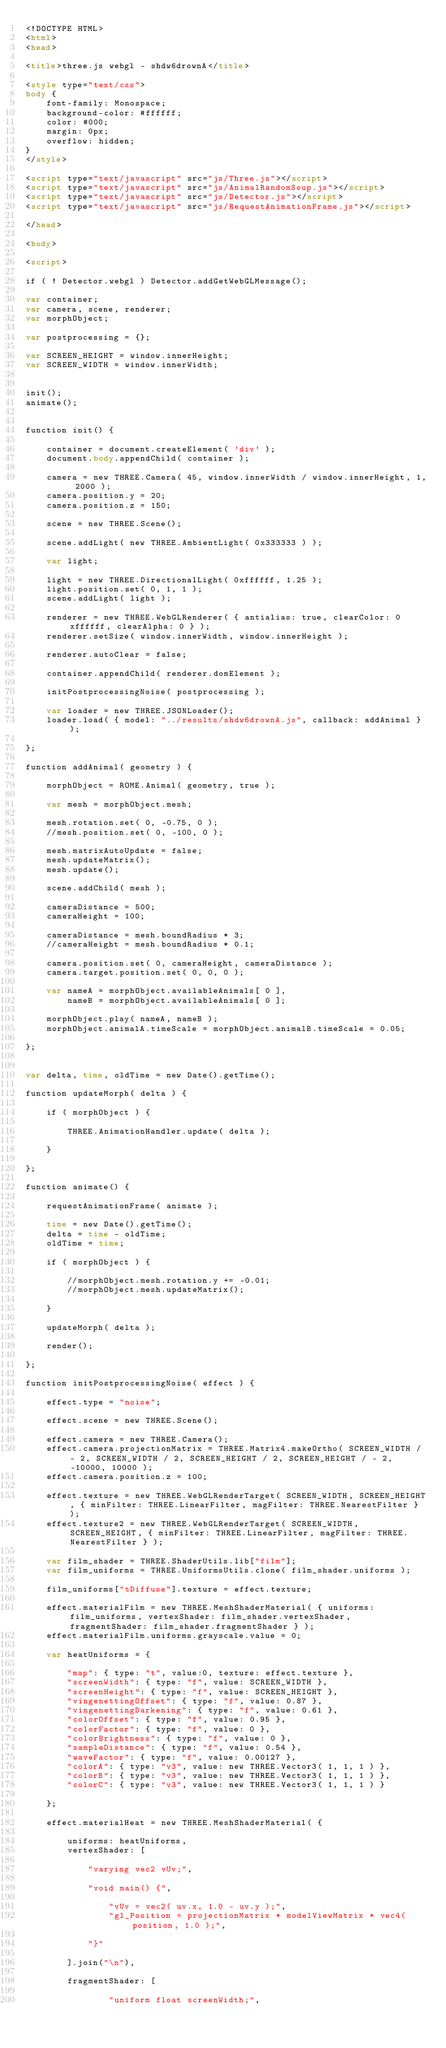Convert code to text. <code><loc_0><loc_0><loc_500><loc_500><_HTML_><!DOCTYPE HTML>
<html>
<head>

<title>three.js webgl - shdw6drownA</title>

<style type="text/css">
body {
    font-family: Monospace;
    background-color: #ffffff;
	color: #000;
    margin: 0px;
    overflow: hidden;
}
</style>

<script type="text/javascript" src="js/Three.js"></script>
<script type="text/javascript" src="js/AnimalRandomSoup.js"></script>
<script type="text/javascript" src="js/Detector.js"></script>
<script type="text/javascript" src="js/RequestAnimationFrame.js"></script>

</head>

<body>

<script>

if ( ! Detector.webgl ) Detector.addGetWebGLMessage();

var container;
var camera, scene, renderer;
var morphObject;

var postprocessing = {};

var SCREEN_HEIGHT = window.innerHeight;
var SCREEN_WIDTH = window.innerWidth;


init();
animate();


function init() {

    container = document.createElement( 'div' );
    document.body.appendChild( container );

    camera = new THREE.Camera( 45, window.innerWidth / window.innerHeight, 1, 2000 );
    camera.position.y = 20;
    camera.position.z = 150;

    scene = new THREE.Scene();

    scene.addLight( new THREE.AmbientLight( 0x333333 ) );

    var light;

    light = new THREE.DirectionalLight( 0xffffff, 1.25 );
    light.position.set( 0, 1, 1 );
    scene.addLight( light );

    renderer = new THREE.WebGLRenderer( { antialias: true, clearColor: 0xffffff, clearAlpha: 0 } );
    renderer.setSize( window.innerWidth, window.innerHeight );
    
    renderer.autoClear = false;
    
    container.appendChild( renderer.domElement );

    initPostprocessingNoise( postprocessing );

    var loader = new THREE.JSONLoader();
    loader.load( { model: "../results/shdw6drownA.js", callback: addAnimal } );

};

function addAnimal( geometry ) {

    morphObject = ROME.Animal( geometry, true );
    
    var mesh = morphObject.mesh;

    mesh.rotation.set( 0, -0.75, 0 );
    //mesh.position.set( 0, -100, 0 );

    mesh.matrixAutoUpdate = false;
    mesh.updateMatrix();
    mesh.update();
    
    scene.addChild( mesh );

    cameraDistance = 500;
    cameraHeight = 100;

    cameraDistance = mesh.boundRadius * 3;
    //cameraHeight = mesh.boundRadius * 0.1;    

    camera.position.set( 0, cameraHeight, cameraDistance );
    camera.target.position.set( 0, 0, 0 );

    var nameA = morphObject.availableAnimals[ 0 ],
        nameB = morphObject.availableAnimals[ 0 ];

    morphObject.play( nameA, nameB );
    morphObject.animalA.timeScale = morphObject.animalB.timeScale = 0.05;

};


var delta, time, oldTime = new Date().getTime();

function updateMorph( delta ) {

    if ( morphObject ) {
        
        THREE.AnimationHandler.update( delta );
        
    }

};

function animate() {

    requestAnimationFrame( animate );
    
    time = new Date().getTime();
    delta = time - oldTime;
    oldTime = time;

    if ( morphObject ) {
    
        //morphObject.mesh.rotation.y += -0.01;
        //morphObject.mesh.updateMatrix();

    }

    updateMorph( delta );
    
    render();

};

function initPostprocessingNoise( effect ) {
    
    effect.type = "noise";
    
    effect.scene = new THREE.Scene();
    
    effect.camera = new THREE.Camera();
    effect.camera.projectionMatrix = THREE.Matrix4.makeOrtho( SCREEN_WIDTH / - 2, SCREEN_WIDTH / 2, SCREEN_HEIGHT / 2, SCREEN_HEIGHT / - 2, -10000, 10000 );
    effect.camera.position.z = 100;
    
    effect.texture = new THREE.WebGLRenderTarget( SCREEN_WIDTH, SCREEN_HEIGHT, { minFilter: THREE.LinearFilter, magFilter: THREE.NearestFilter } );
    effect.texture2 = new THREE.WebGLRenderTarget( SCREEN_WIDTH, SCREEN_HEIGHT, { minFilter: THREE.LinearFilter, magFilter: THREE.NearestFilter } );

    var film_shader = THREE.ShaderUtils.lib["film"];
    var film_uniforms = THREE.UniformsUtils.clone( film_shader.uniforms );
    
    film_uniforms["tDiffuse"].texture = effect.texture;
    
    effect.materialFilm = new THREE.MeshShaderMaterial( { uniforms: film_uniforms, vertexShader: film_shader.vertexShader, fragmentShader: film_shader.fragmentShader } );
    effect.materialFilm.uniforms.grayscale.value = 0;
    
    var heatUniforms = {

		"map": { type: "t", value:0, texture: effect.texture },
		"screenWidth": { type: "f", value: SCREEN_WIDTH },
		"screenHeight": { type: "f", value: SCREEN_HEIGHT },
		"vingenettingOffset": { type: "f", value: 0.87 },
		"vingenettingDarkening": { type: "f", value: 0.61 },
		"colorOffset": { type: "f", value: 0.95 },
		"colorFactor": { type: "f", value: 0 },
		"colorBrightness": { type: "f", value: 0 },
		"sampleDistance": { type: "f", value: 0.54 },
		"waveFactor": { type: "f", value: 0.00127 },
		"colorA": { type: "v3", value: new THREE.Vector3( 1, 1, 1 ) },
		"colorB": { type: "v3", value: new THREE.Vector3( 1, 1, 1 ) },
		"colorC": { type: "v3", value: new THREE.Vector3( 1, 1, 1 ) }

    };

    effect.materialHeat = new THREE.MeshShaderMaterial( {

        uniforms: heatUniforms,
        vertexShader: [

            "varying vec2 vUv;",

            "void main() {",

                "vUv = vec2( uv.x, 1.0 - uv.y );",
                "gl_Position = projectionMatrix * modelViewMatrix * vec4( position, 1.0 );",

            "}"

        ].join("\n"),
        
        fragmentShader: [

				"uniform float screenWidth;",</code> 